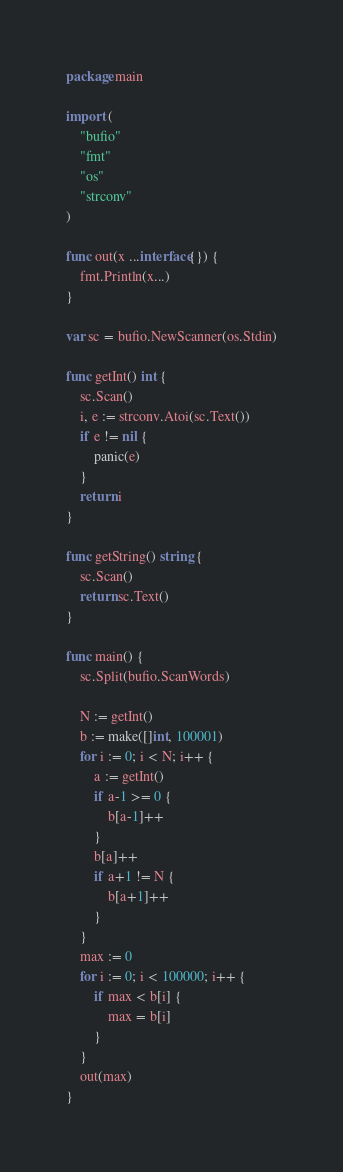<code> <loc_0><loc_0><loc_500><loc_500><_Go_>package main

import (
	"bufio"
	"fmt"
	"os"
	"strconv"
)

func out(x ...interface{}) {
	fmt.Println(x...)
}

var sc = bufio.NewScanner(os.Stdin)

func getInt() int {
	sc.Scan()
	i, e := strconv.Atoi(sc.Text())
	if e != nil {
		panic(e)
	}
	return i
}

func getString() string {
	sc.Scan()
	return sc.Text()
}

func main() {
	sc.Split(bufio.ScanWords)

	N := getInt()
	b := make([]int, 100001)
	for i := 0; i < N; i++ {
		a := getInt()
		if a-1 >= 0 {
			b[a-1]++
		}
		b[a]++
		if a+1 != N {
			b[a+1]++
		}
	}
	max := 0
	for i := 0; i < 100000; i++ {
		if max < b[i] {
			max = b[i]
		}
	}
	out(max)
}
</code> 